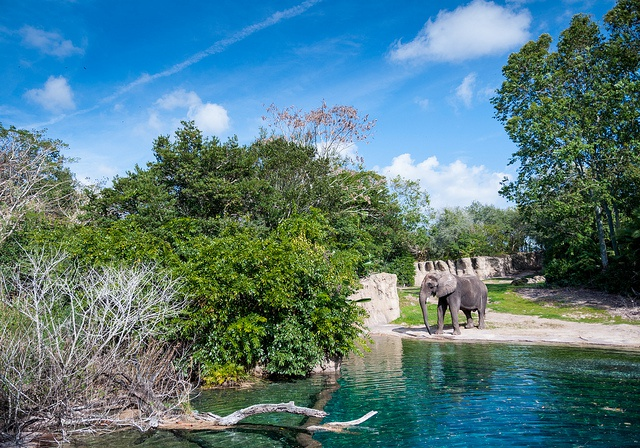Describe the objects in this image and their specific colors. I can see a elephant in blue, gray, darkgray, and black tones in this image. 